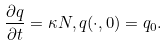Convert formula to latex. <formula><loc_0><loc_0><loc_500><loc_500>\frac { \partial q } { \partial t } = \kappa N , q ( \cdot , 0 ) = q _ { 0 } .</formula> 